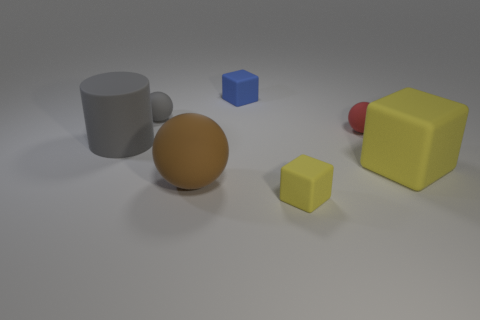Add 2 small gray rubber objects. How many objects exist? 9 Subtract all cylinders. How many objects are left? 6 Add 7 tiny gray balls. How many tiny gray balls exist? 8 Subtract 0 green blocks. How many objects are left? 7 Subtract all large gray things. Subtract all tiny blue metal cylinders. How many objects are left? 6 Add 7 big blocks. How many big blocks are left? 8 